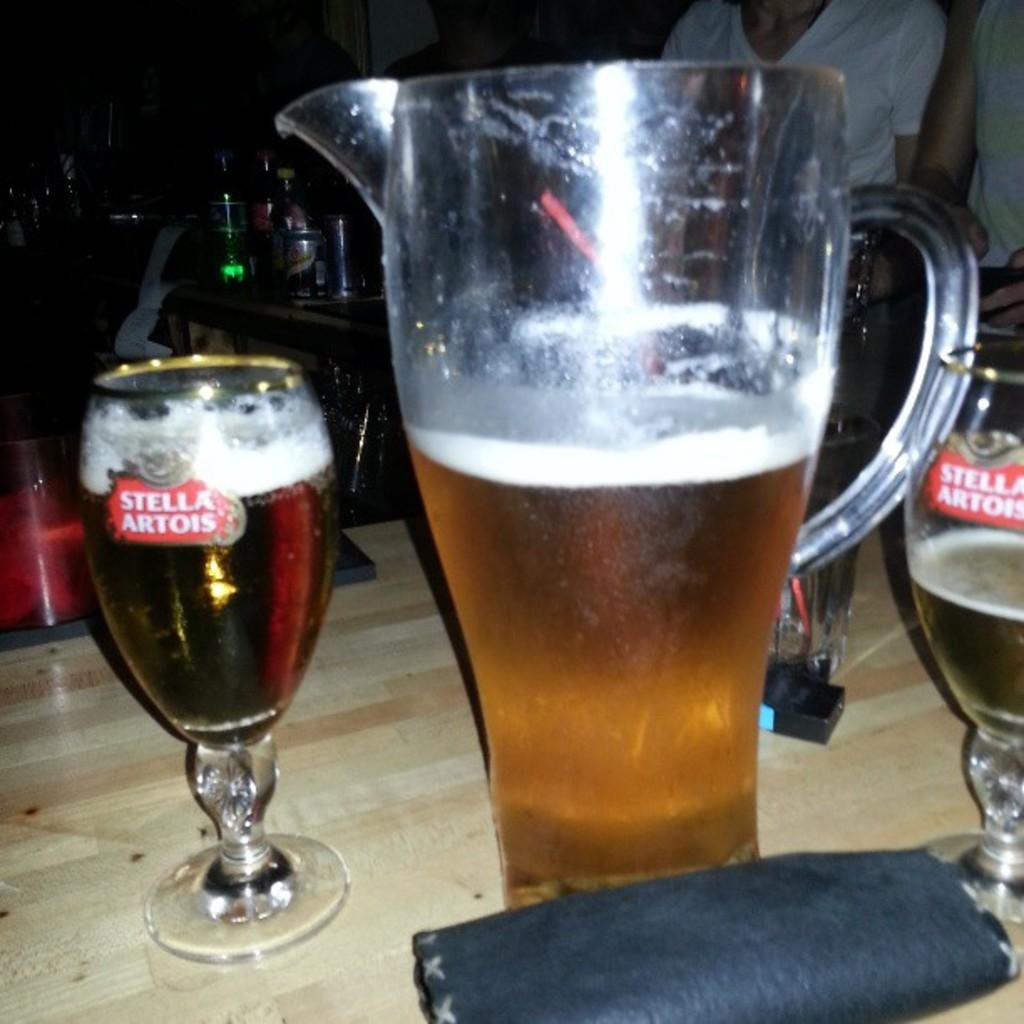<image>
Summarize the visual content of the image. A pitcher of beer is poured into Stella Artois glasses. 